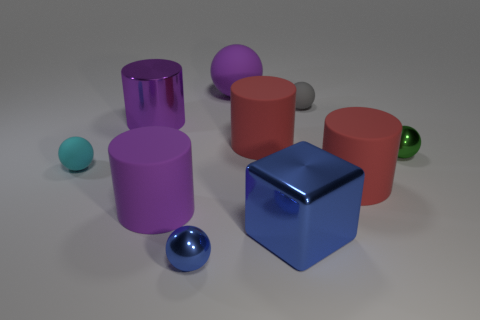Subtract all purple rubber balls. How many balls are left? 4 Subtract all green spheres. How many spheres are left? 4 Subtract all yellow spheres. Subtract all green cylinders. How many spheres are left? 5 Subtract all cylinders. How many objects are left? 6 Add 1 shiny things. How many shiny things are left? 5 Add 2 tiny gray spheres. How many tiny gray spheres exist? 3 Subtract 0 cyan cylinders. How many objects are left? 10 Subtract all large blue metallic objects. Subtract all big metallic things. How many objects are left? 7 